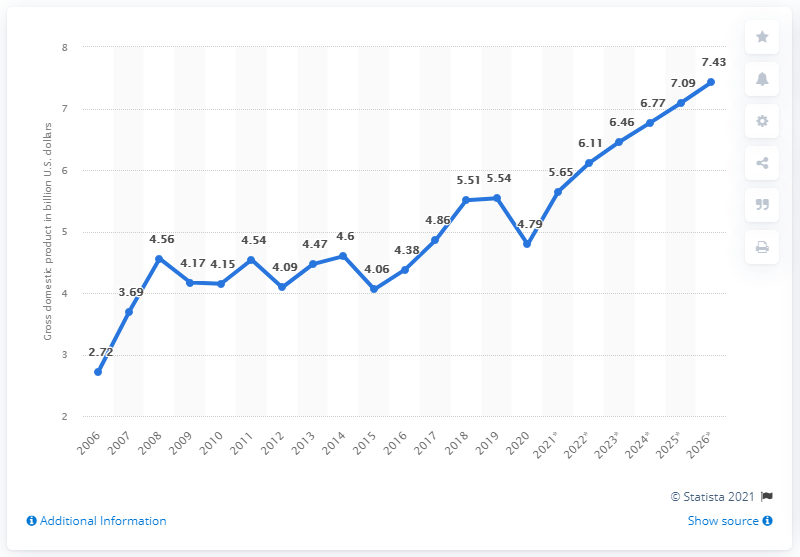Highlight a few significant elements in this photo. In 2020, the gross domestic product of Montenegro was 4.79 billion dollars. 